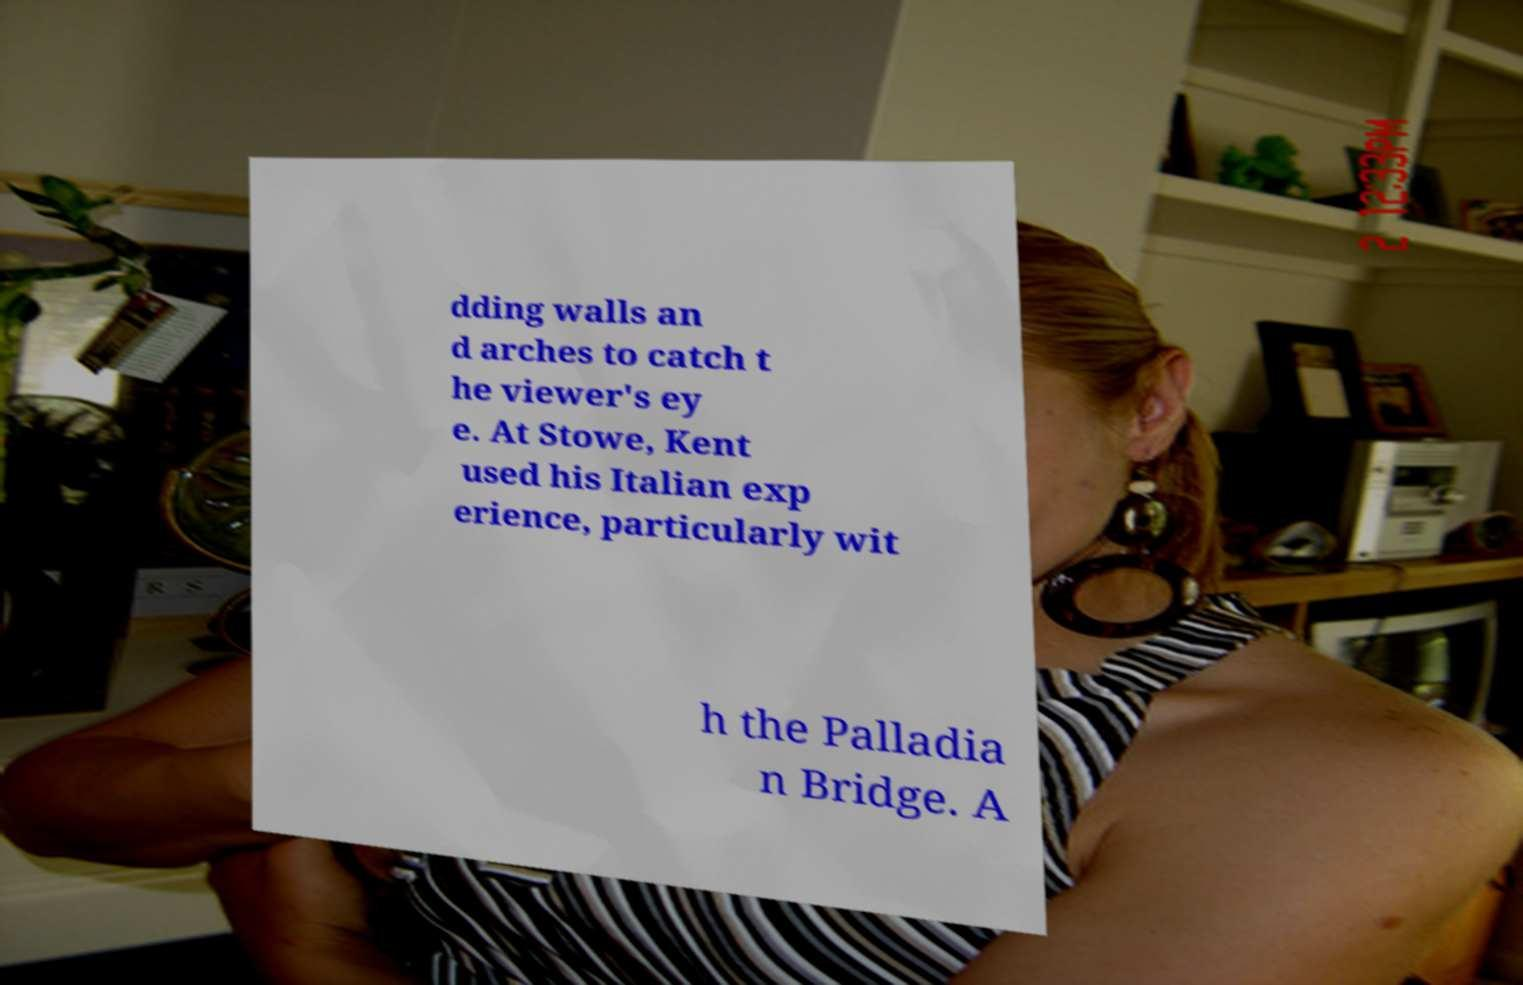What messages or text are displayed in this image? I need them in a readable, typed format. dding walls an d arches to catch t he viewer's ey e. At Stowe, Kent used his Italian exp erience, particularly wit h the Palladia n Bridge. A 